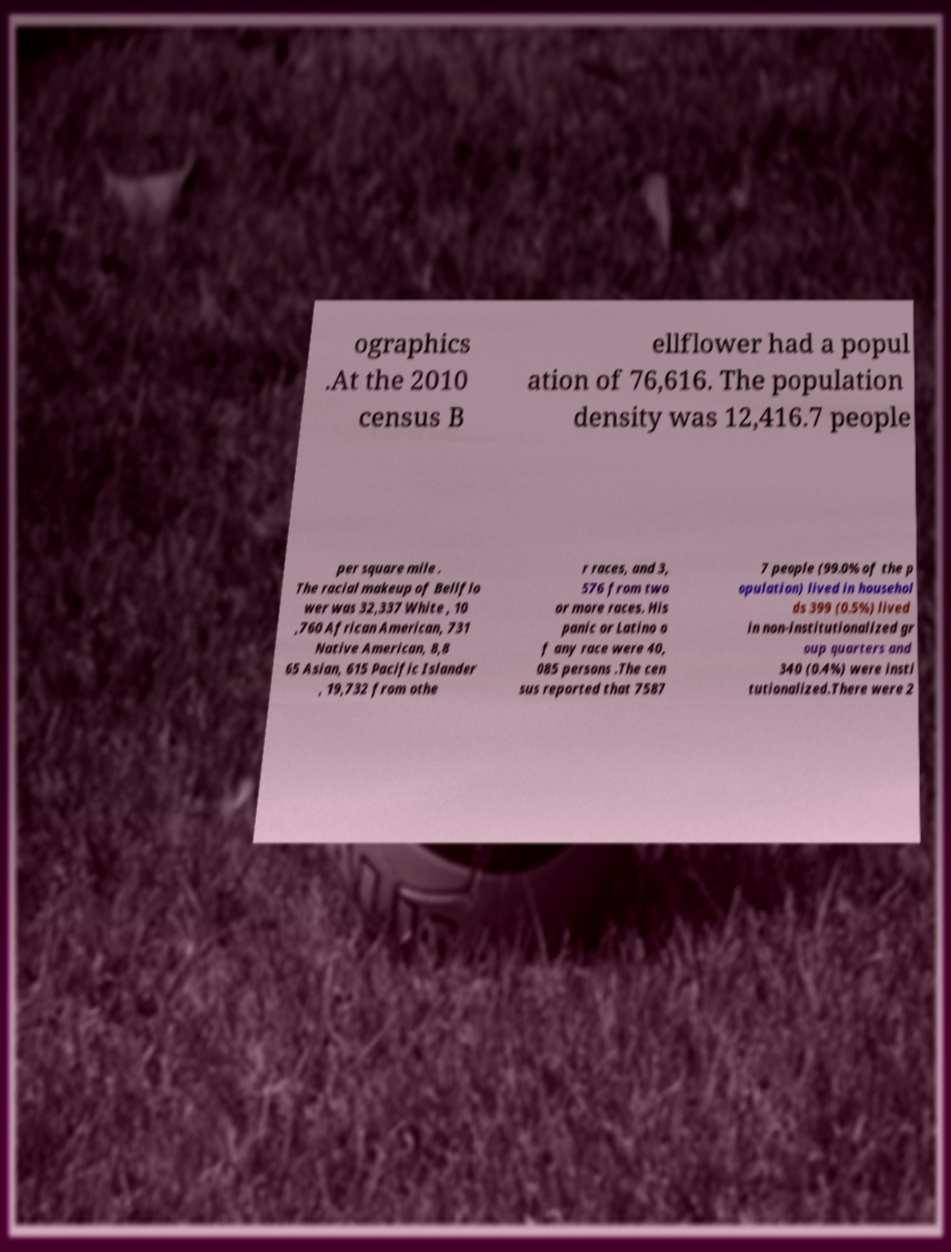Could you assist in decoding the text presented in this image and type it out clearly? ographics .At the 2010 census B ellflower had a popul ation of 76,616. The population density was 12,416.7 people per square mile . The racial makeup of Bellflo wer was 32,337 White , 10 ,760 African American, 731 Native American, 8,8 65 Asian, 615 Pacific Islander , 19,732 from othe r races, and 3, 576 from two or more races. His panic or Latino o f any race were 40, 085 persons .The cen sus reported that 7587 7 people (99.0% of the p opulation) lived in househol ds 399 (0.5%) lived in non-institutionalized gr oup quarters and 340 (0.4%) were insti tutionalized.There were 2 